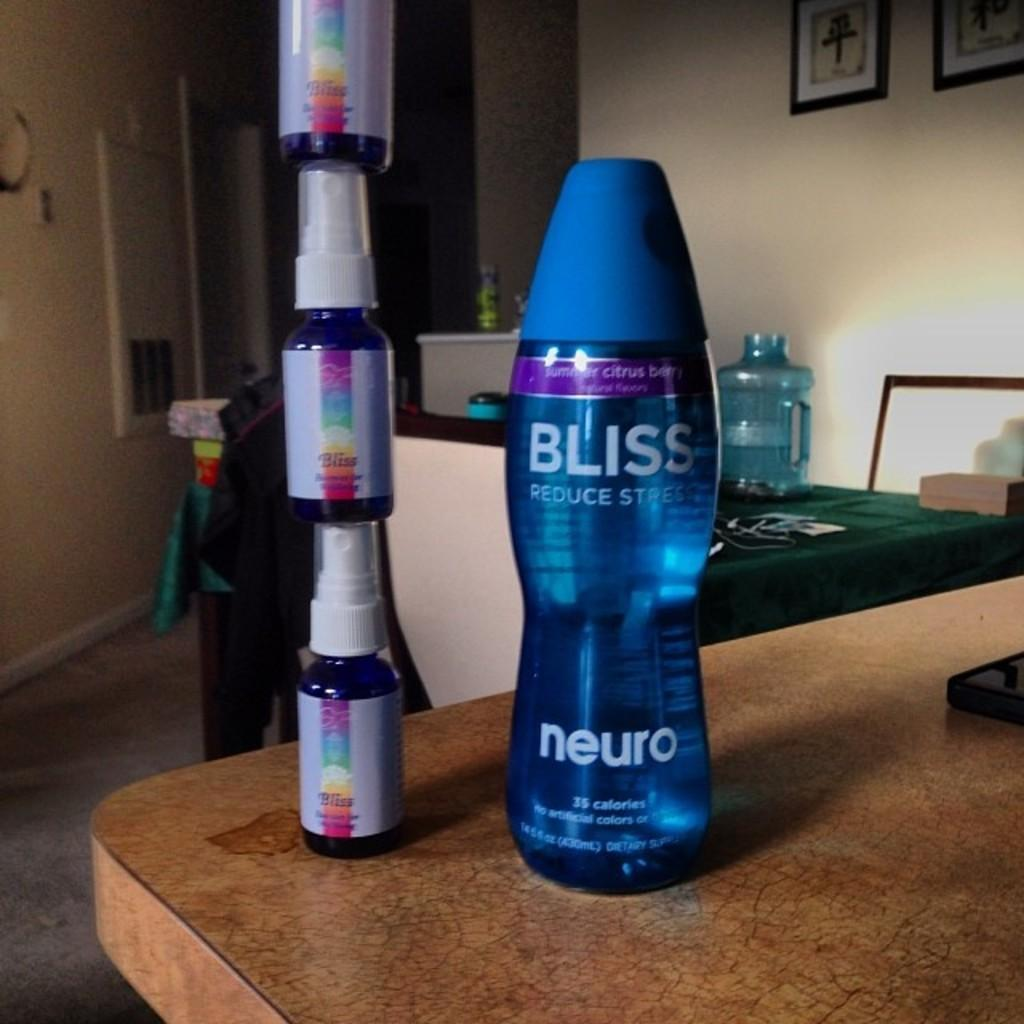<image>
Describe the image concisely. Three bottles of Bliss spray are stacked upon one another and next to a large bottle of Bliss. 